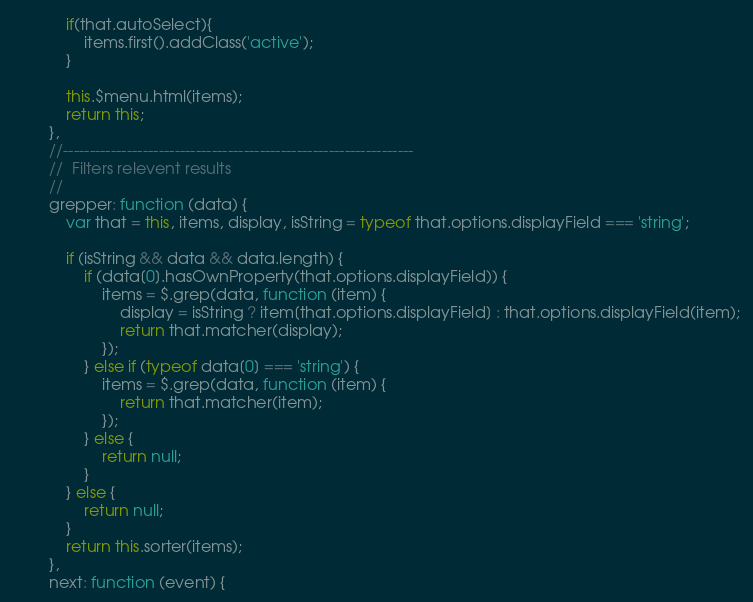<code> <loc_0><loc_0><loc_500><loc_500><_JavaScript_>
            if(that.autoSelect){
                items.first().addClass('active');
            }

            this.$menu.html(items);
            return this;
        },
        //------------------------------------------------------------------
        //  Filters relevent results
        //
        grepper: function (data) {
            var that = this, items, display, isString = typeof that.options.displayField === 'string';

            if (isString && data && data.length) {
                if (data[0].hasOwnProperty(that.options.displayField)) {
                    items = $.grep(data, function (item) {
                        display = isString ? item[that.options.displayField] : that.options.displayField(item);
                        return that.matcher(display);
                    });
                } else if (typeof data[0] === 'string') {
                    items = $.grep(data, function (item) {
                        return that.matcher(item);
                    });
                } else {
                    return null;
                }
            } else {
                return null;
            }
            return this.sorter(items);
        },
        next: function (event) {</code> 